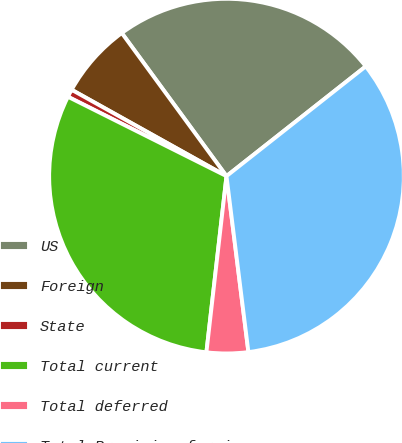Convert chart to OTSL. <chart><loc_0><loc_0><loc_500><loc_500><pie_chart><fcel>US<fcel>Foreign<fcel>State<fcel>Total current<fcel>Total deferred<fcel>Total Provision for income<nl><fcel>24.43%<fcel>6.85%<fcel>0.71%<fcel>30.58%<fcel>3.78%<fcel>33.65%<nl></chart> 